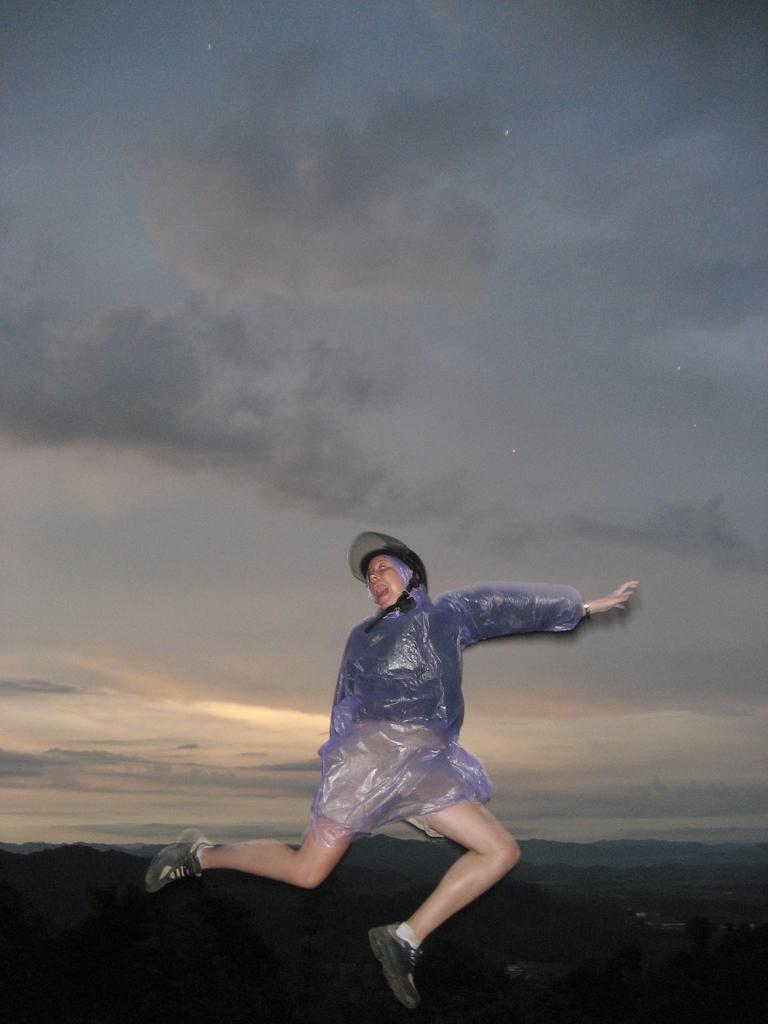What is the person in the image doing? There is a person in the air, which suggests they might be paragliding or skydiving. What can be seen in the distance behind the person? There are mountains in the background of the image. How would you describe the weather in the image? The sky is cloudy in the image. What type of roll can be seen on the person's head in the image? There is no roll visible on the person's head in the image. What place is the person trying to reach by paragliding in the image? The image does not provide enough information to determine the person's destination or purpose for paragliding. 